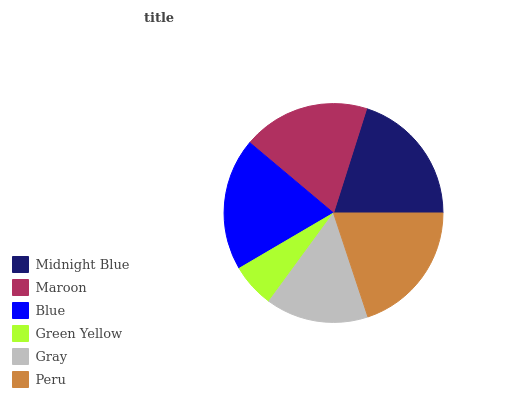Is Green Yellow the minimum?
Answer yes or no. Yes. Is Midnight Blue the maximum?
Answer yes or no. Yes. Is Maroon the minimum?
Answer yes or no. No. Is Maroon the maximum?
Answer yes or no. No. Is Midnight Blue greater than Maroon?
Answer yes or no. Yes. Is Maroon less than Midnight Blue?
Answer yes or no. Yes. Is Maroon greater than Midnight Blue?
Answer yes or no. No. Is Midnight Blue less than Maroon?
Answer yes or no. No. Is Blue the high median?
Answer yes or no. Yes. Is Maroon the low median?
Answer yes or no. Yes. Is Peru the high median?
Answer yes or no. No. Is Blue the low median?
Answer yes or no. No. 